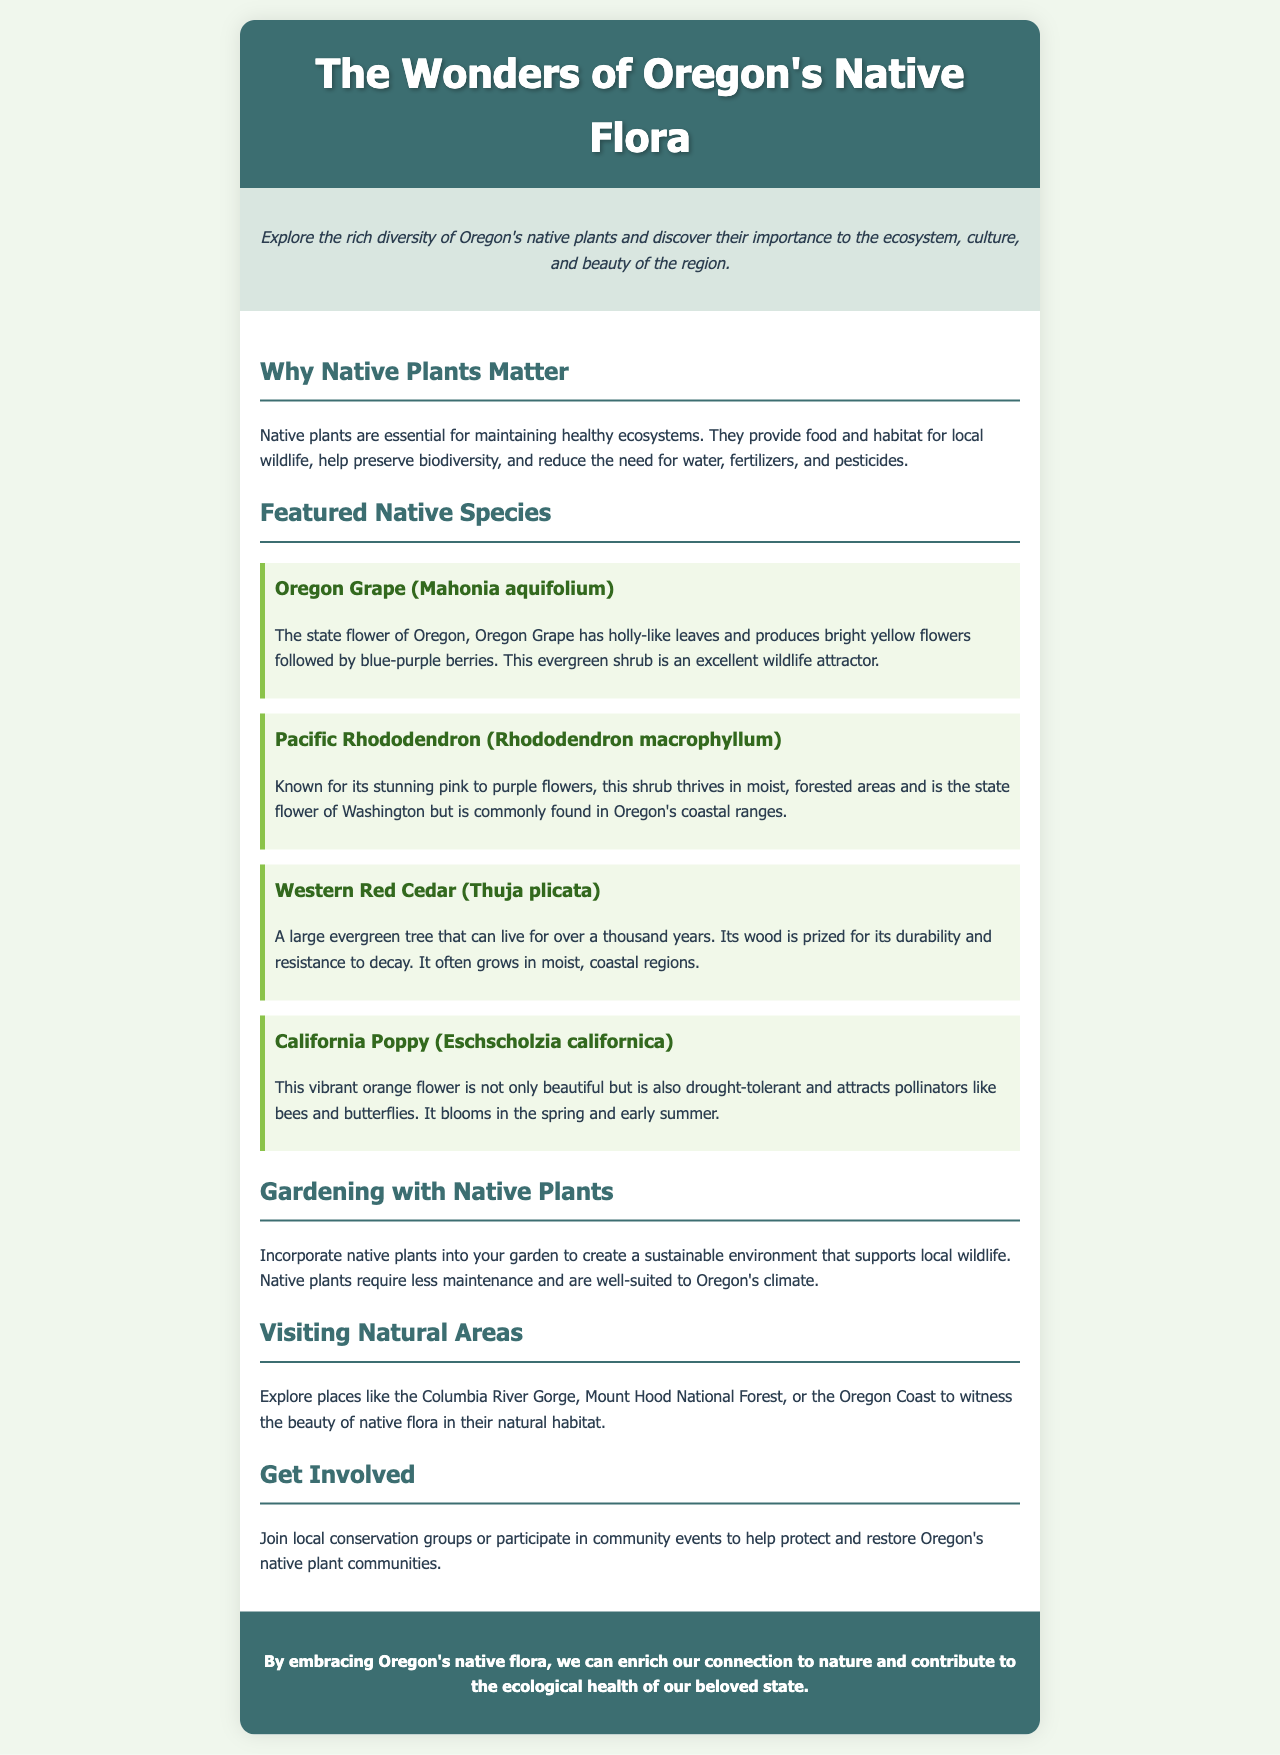What is the title of the brochure? The title is presented prominently at the top of the document.
Answer: The Wonders of Oregon's Native Flora What is the state flower of Oregon? The state flower is specifically mentioned in the section about featured native species.
Answer: Oregon Grape How many featured native species are listed in the brochure? The number of featured species can be counted in the relevant section of the document.
Answer: Four Which shrub is known for its stunning pink to purple flowers? This is described in the section featuring native species, where the characteristics of the shrub are detailed.
Answer: Pacific Rhododendron What benefit do native plants provide for local wildlife? This information is stated in the section explaining why native plants matter.
Answer: Food and habitat Where can you witness Oregon's native flora in their natural habitat? The document lists specific locations where this can be experienced.
Answer: Columbia River Gorge What should you consider when gardening with native plants? The section on gardening with native plants provides advice on maintaining sustainability.
Answer: Sustainable environment How can individuals contribute to preserving native plant communities? Solutions for getting involved are outlined in the relevant section of the brochure.
Answer: Join local conservation groups 